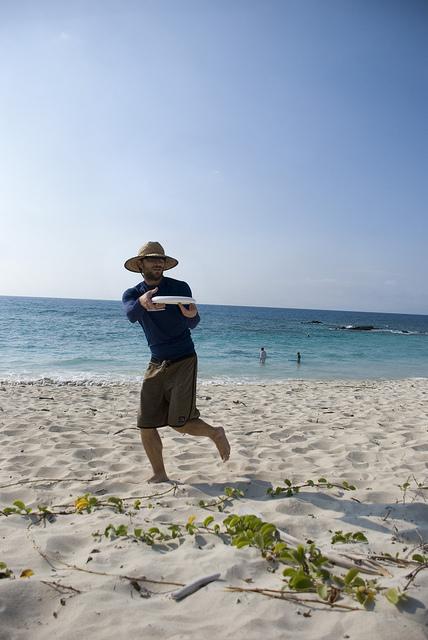Is it raining in this photo?
Keep it brief. No. Is the man flying a kite?
Quick response, please. No. What is the boy doing?
Be succinct. Frisbee. What is the person's suit made of?
Short answer required. Cloth. What is in the air?
Quick response, please. Frisbee. What is this man on the beach doing with his hands?
Quick response, please. Catching frisbee. What is this person holding?
Keep it brief. Frisbee. What sport is he doing?
Concise answer only. Frisbee. Is the water clear?
Answer briefly. Yes. What is in the far background?
Give a very brief answer. Ocean. What is at the man's feet?
Write a very short answer. Sand. 